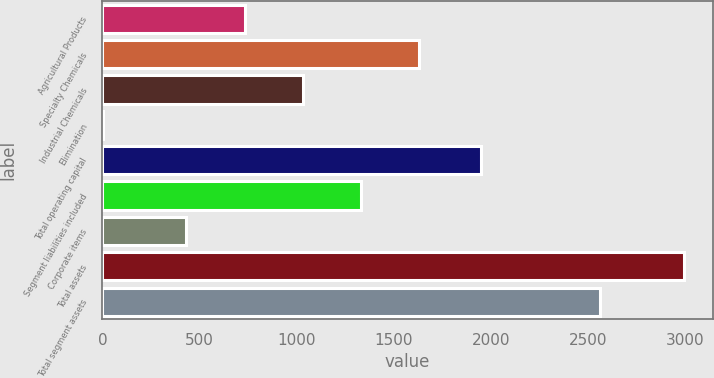Convert chart to OTSL. <chart><loc_0><loc_0><loc_500><loc_500><bar_chart><fcel>Agricultural Products<fcel>Specialty Chemicals<fcel>Industrial Chemicals<fcel>Elimination<fcel>Total operating capital<fcel>Segment liabilities included<fcel>Corporate items<fcel>Total assets<fcel>Total segment assets<nl><fcel>731.95<fcel>1630<fcel>1031.3<fcel>0.4<fcel>1947.6<fcel>1330.65<fcel>432.6<fcel>2993.9<fcel>2561.3<nl></chart> 